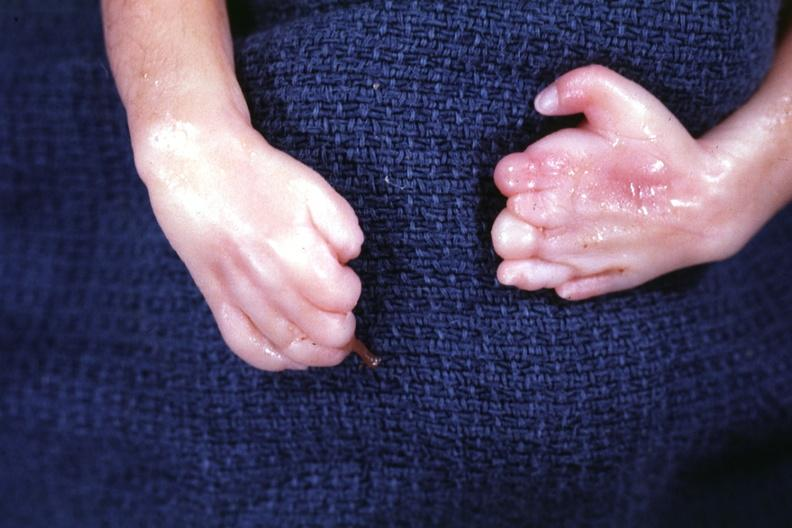re extremities present?
Answer the question using a single word or phrase. Extremities 